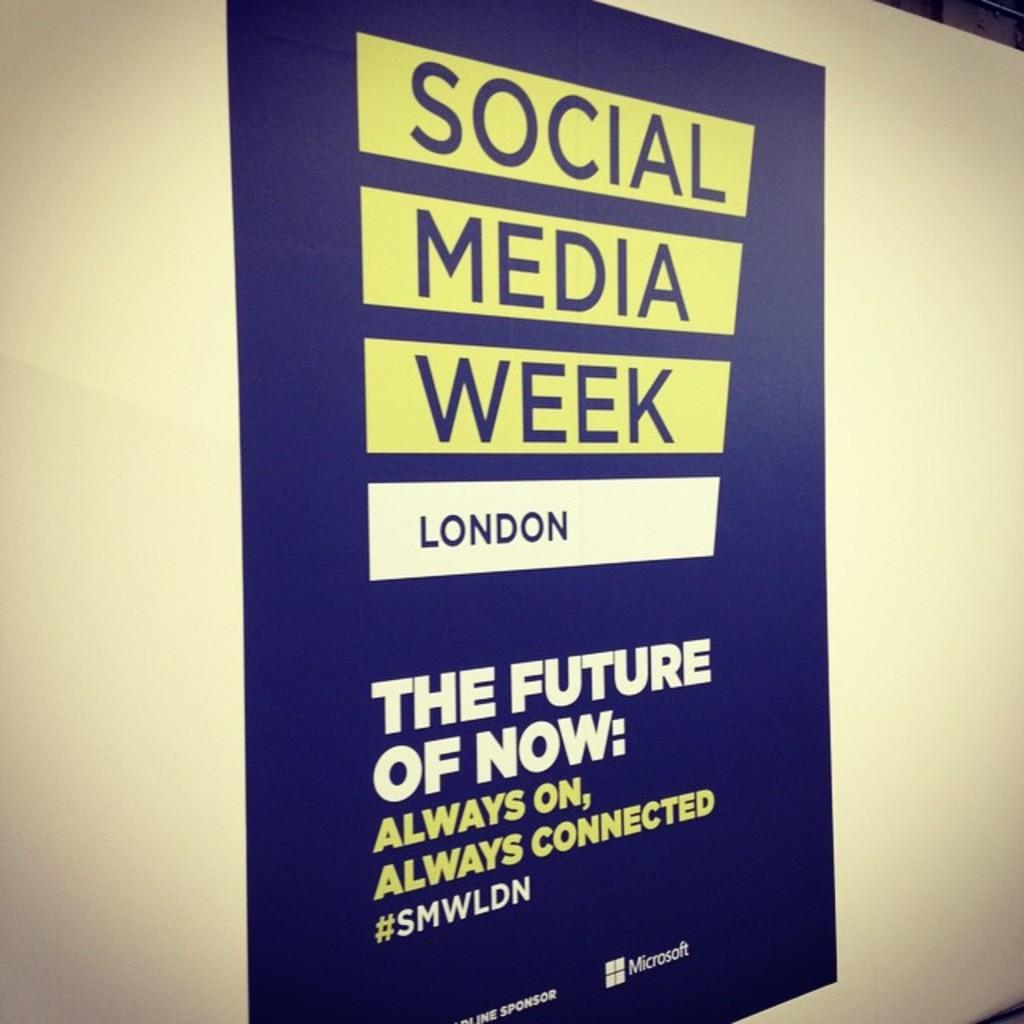<image>
Share a concise interpretation of the image provided. A social media week poster for london sponsored by microsoft 